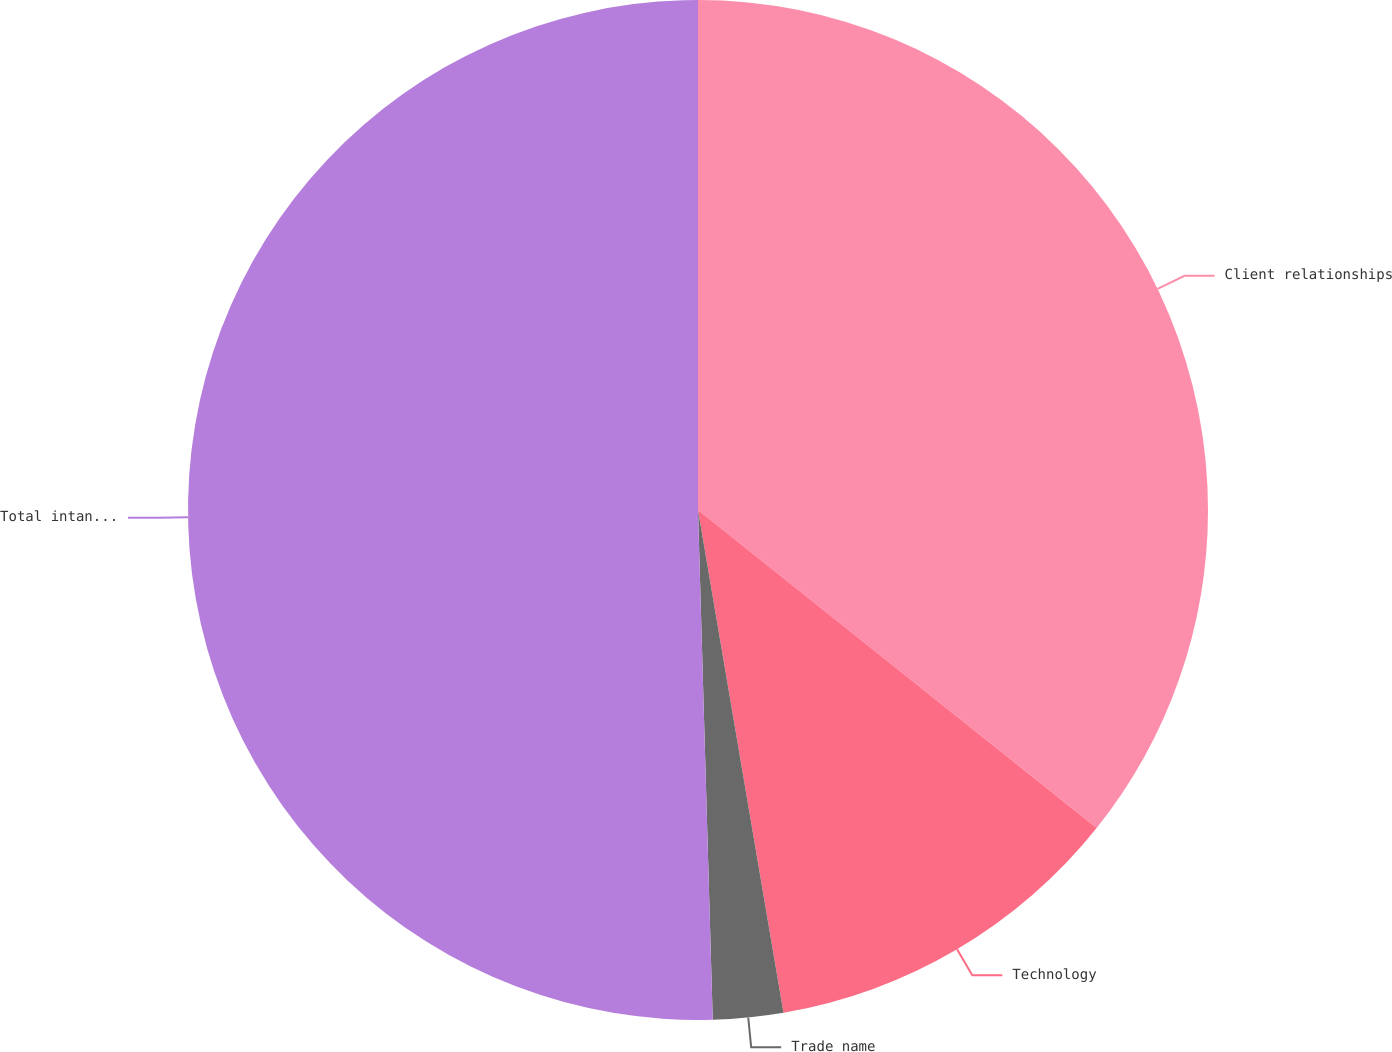Convert chart to OTSL. <chart><loc_0><loc_0><loc_500><loc_500><pie_chart><fcel>Client relationships<fcel>Technology<fcel>Trade name<fcel>Total intangible assets<nl><fcel>35.72%<fcel>11.6%<fcel>2.22%<fcel>50.46%<nl></chart> 